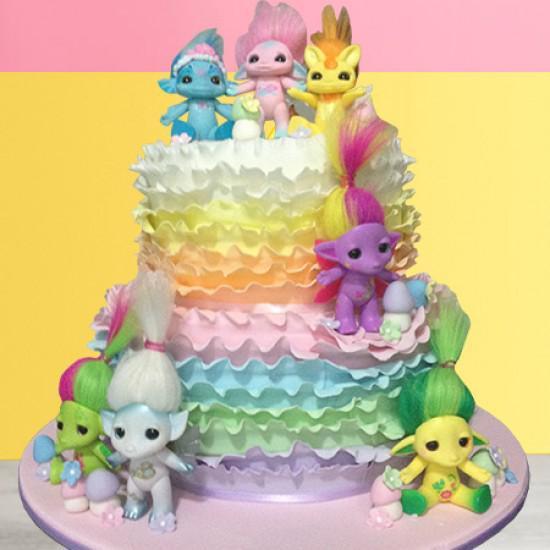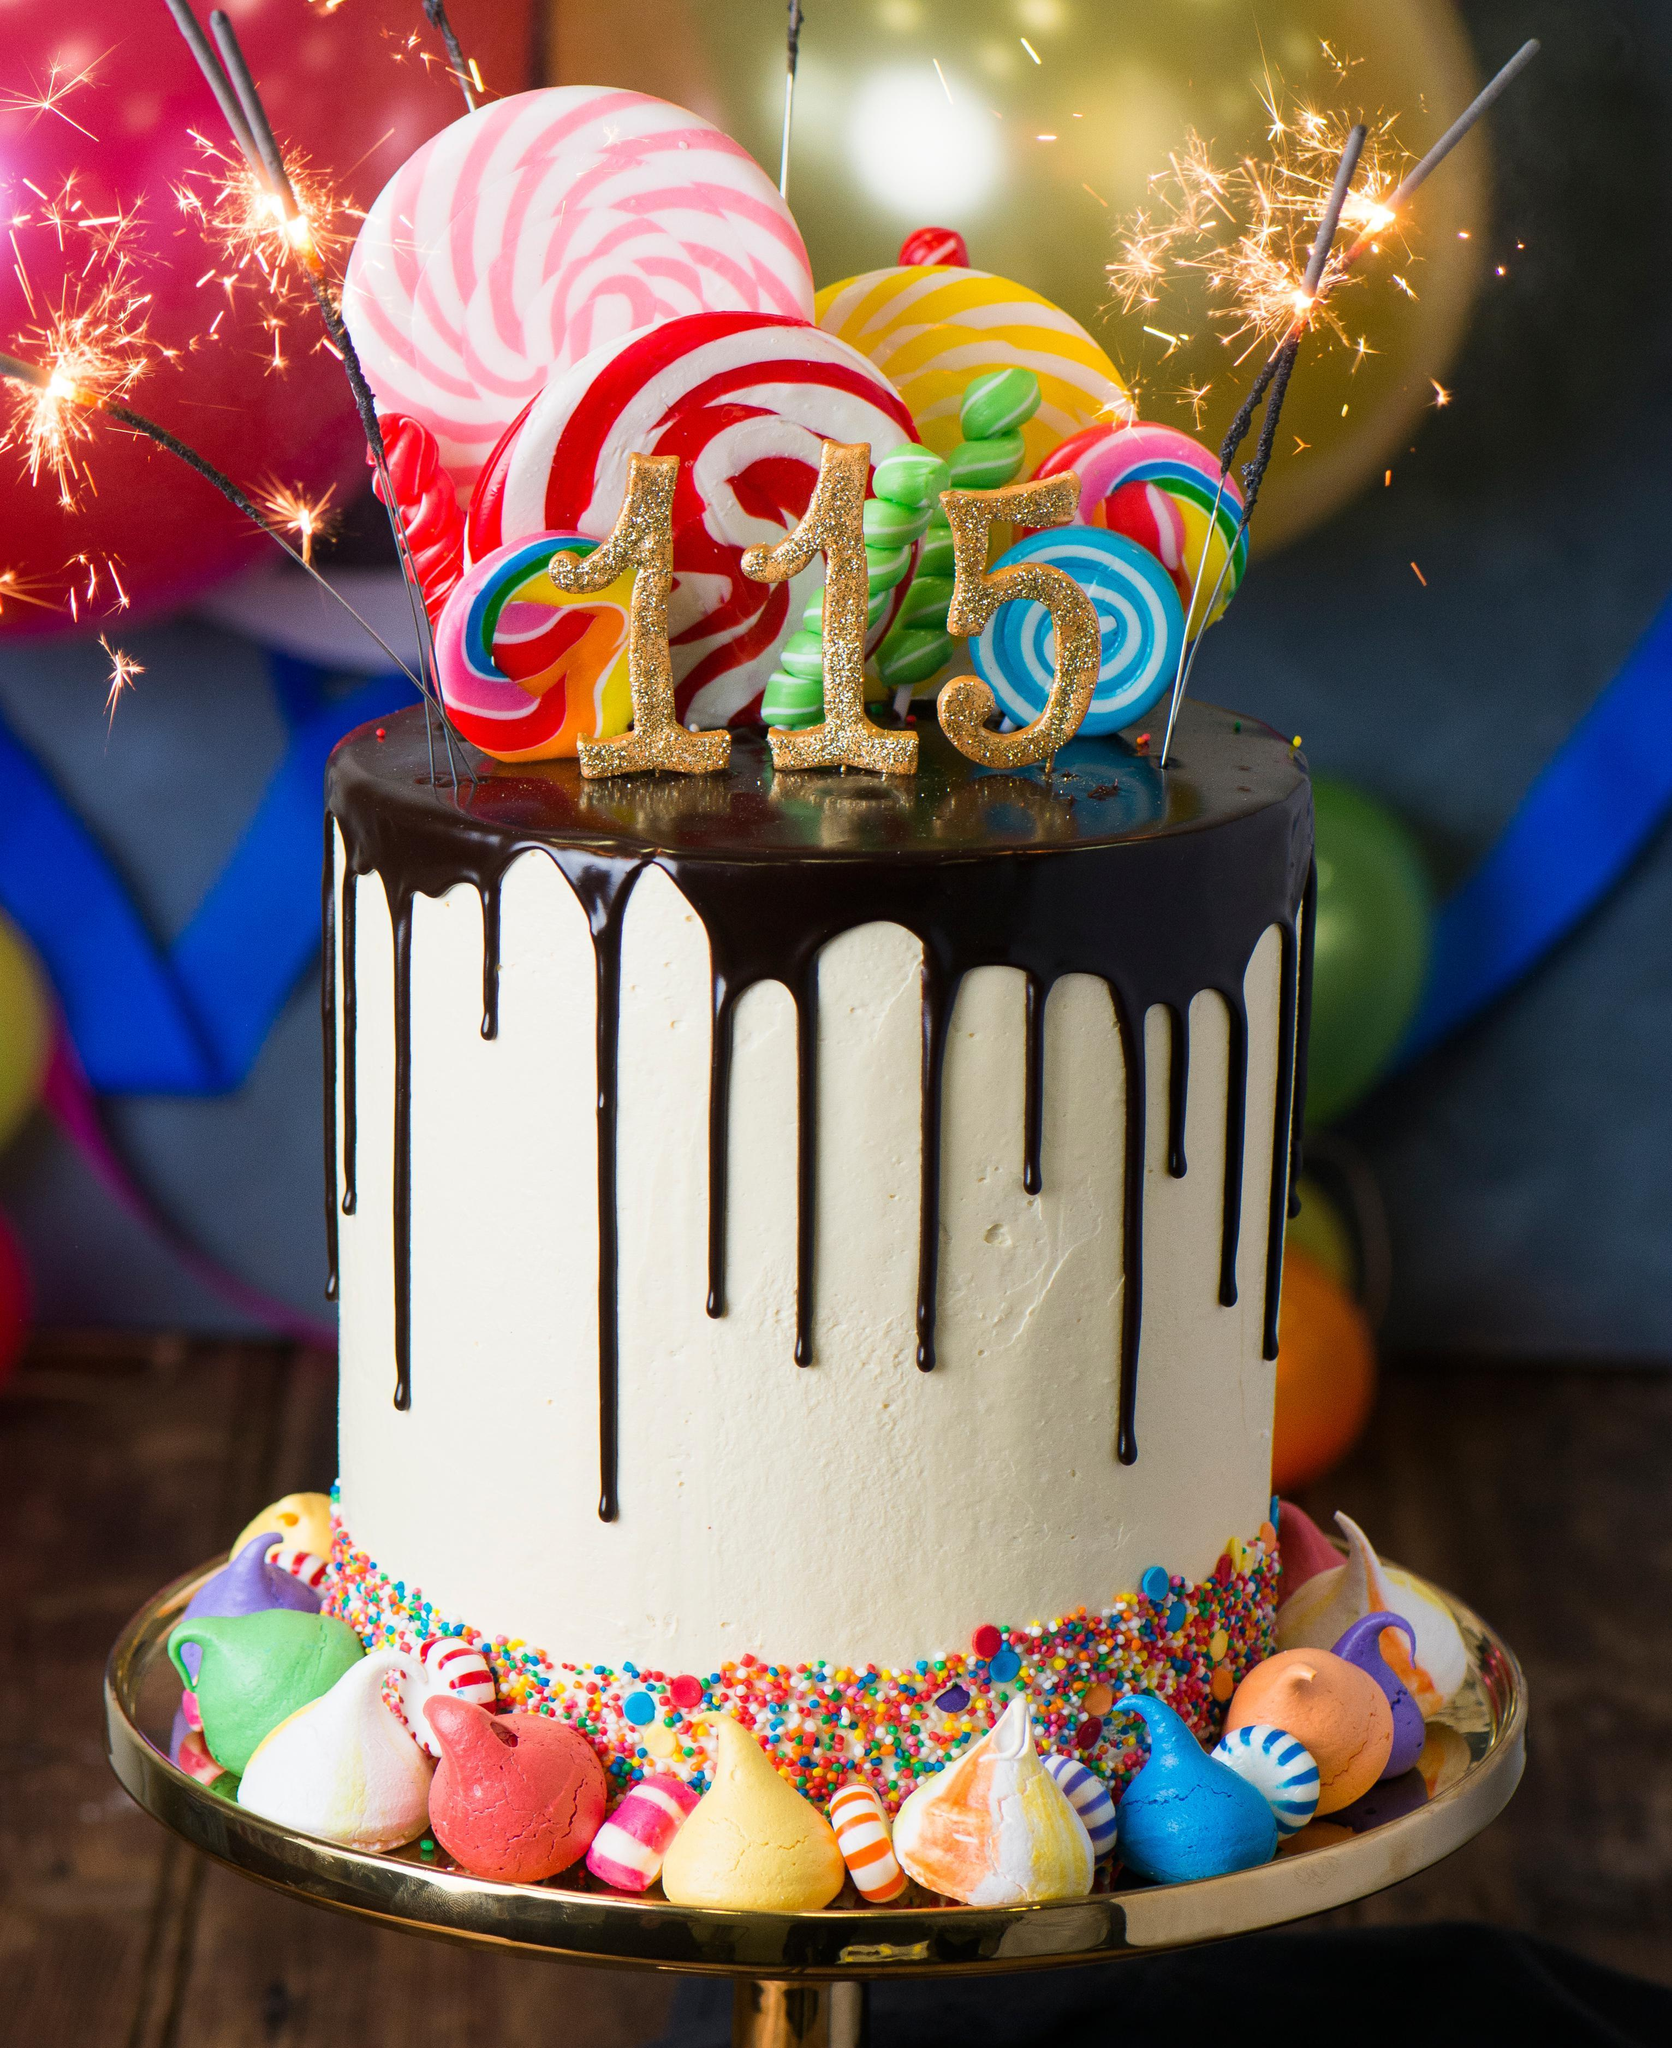The first image is the image on the left, the second image is the image on the right. Evaluate the accuracy of this statement regarding the images: "In at least one image there is an ice cream cone on top of a frosting drip cake.". Is it true? Answer yes or no. No. The first image is the image on the left, the second image is the image on the right. For the images displayed, is the sentence "Each image contains one cake with drip frosting effect and a ring of confetti sprinkles around the bottom, and the cake on the right has an inverted ice cream cone on its top." factually correct? Answer yes or no. No. 